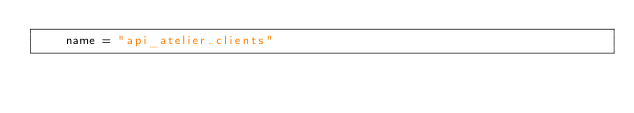Convert code to text. <code><loc_0><loc_0><loc_500><loc_500><_Python_>    name = "api_atelier.clients"
</code> 